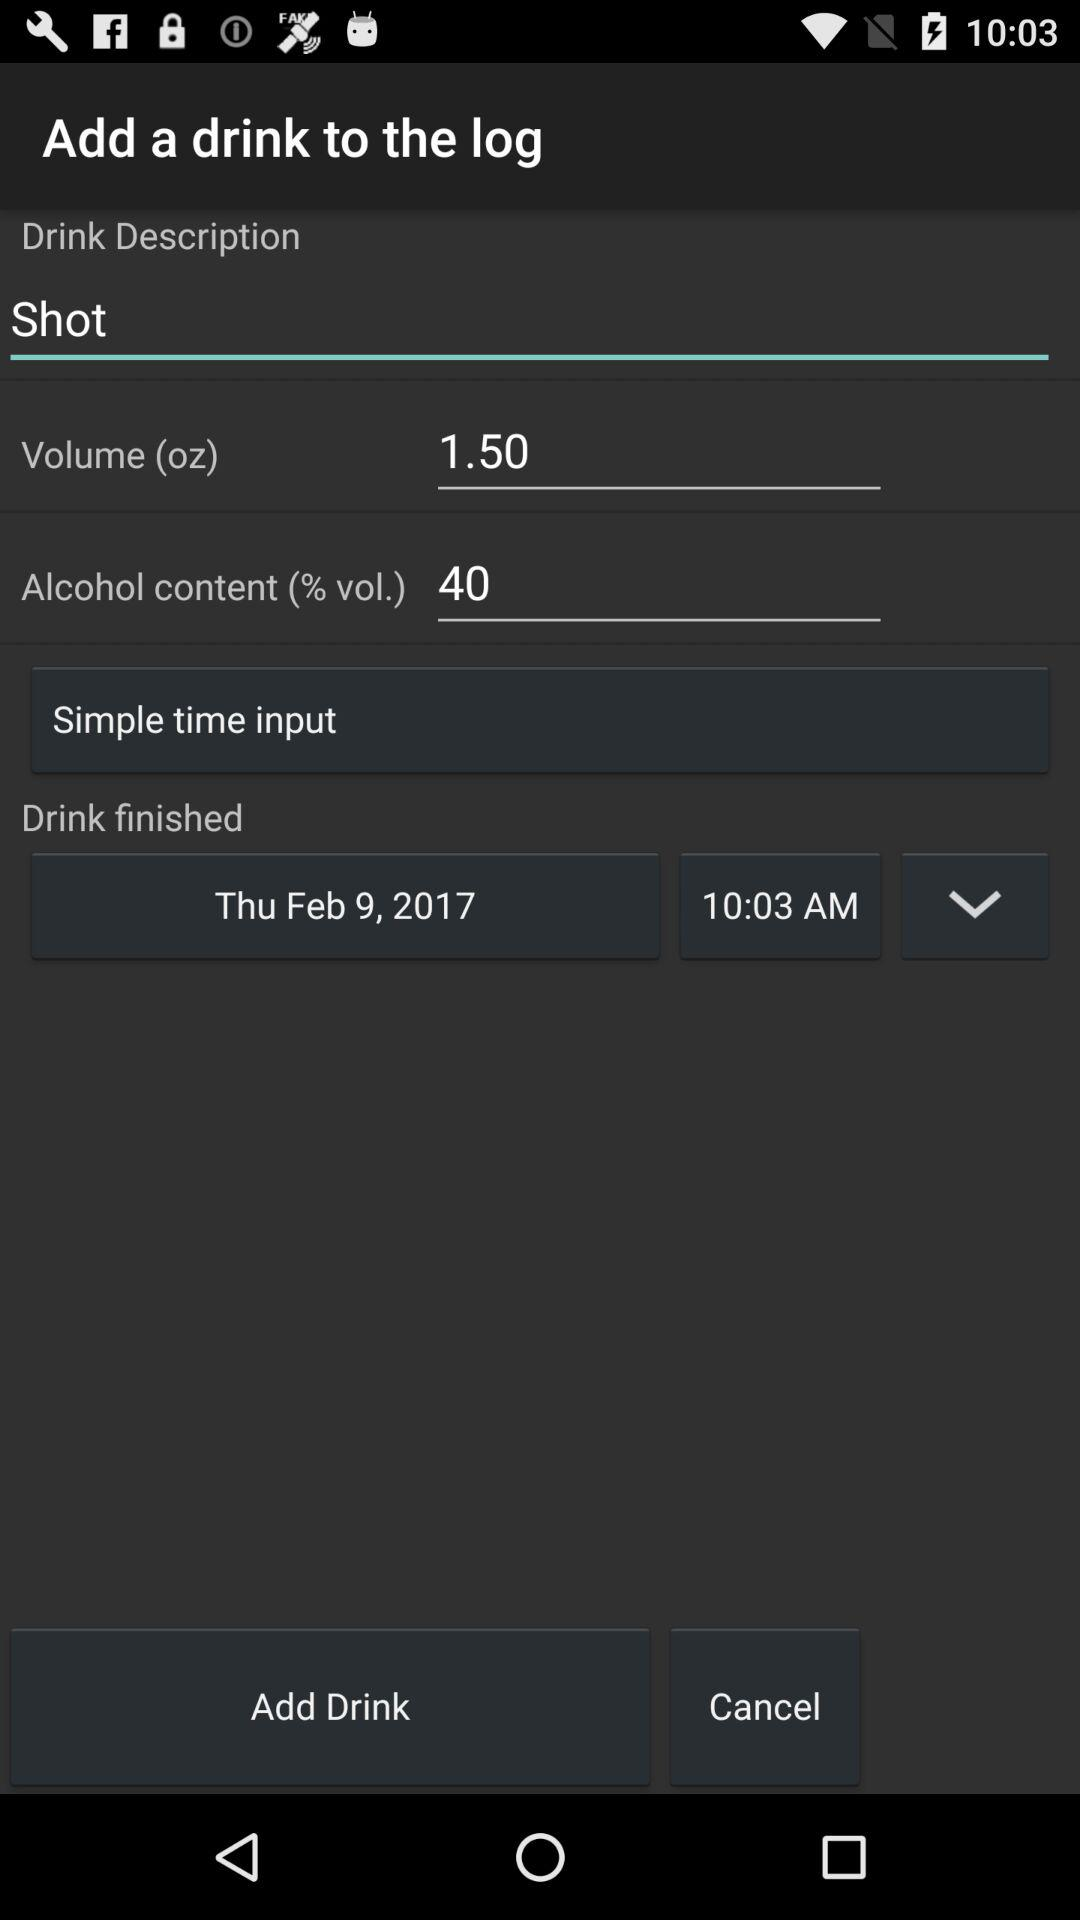What type of alcohol was in the shot?
When the provided information is insufficient, respond with <no answer>. <no answer> 